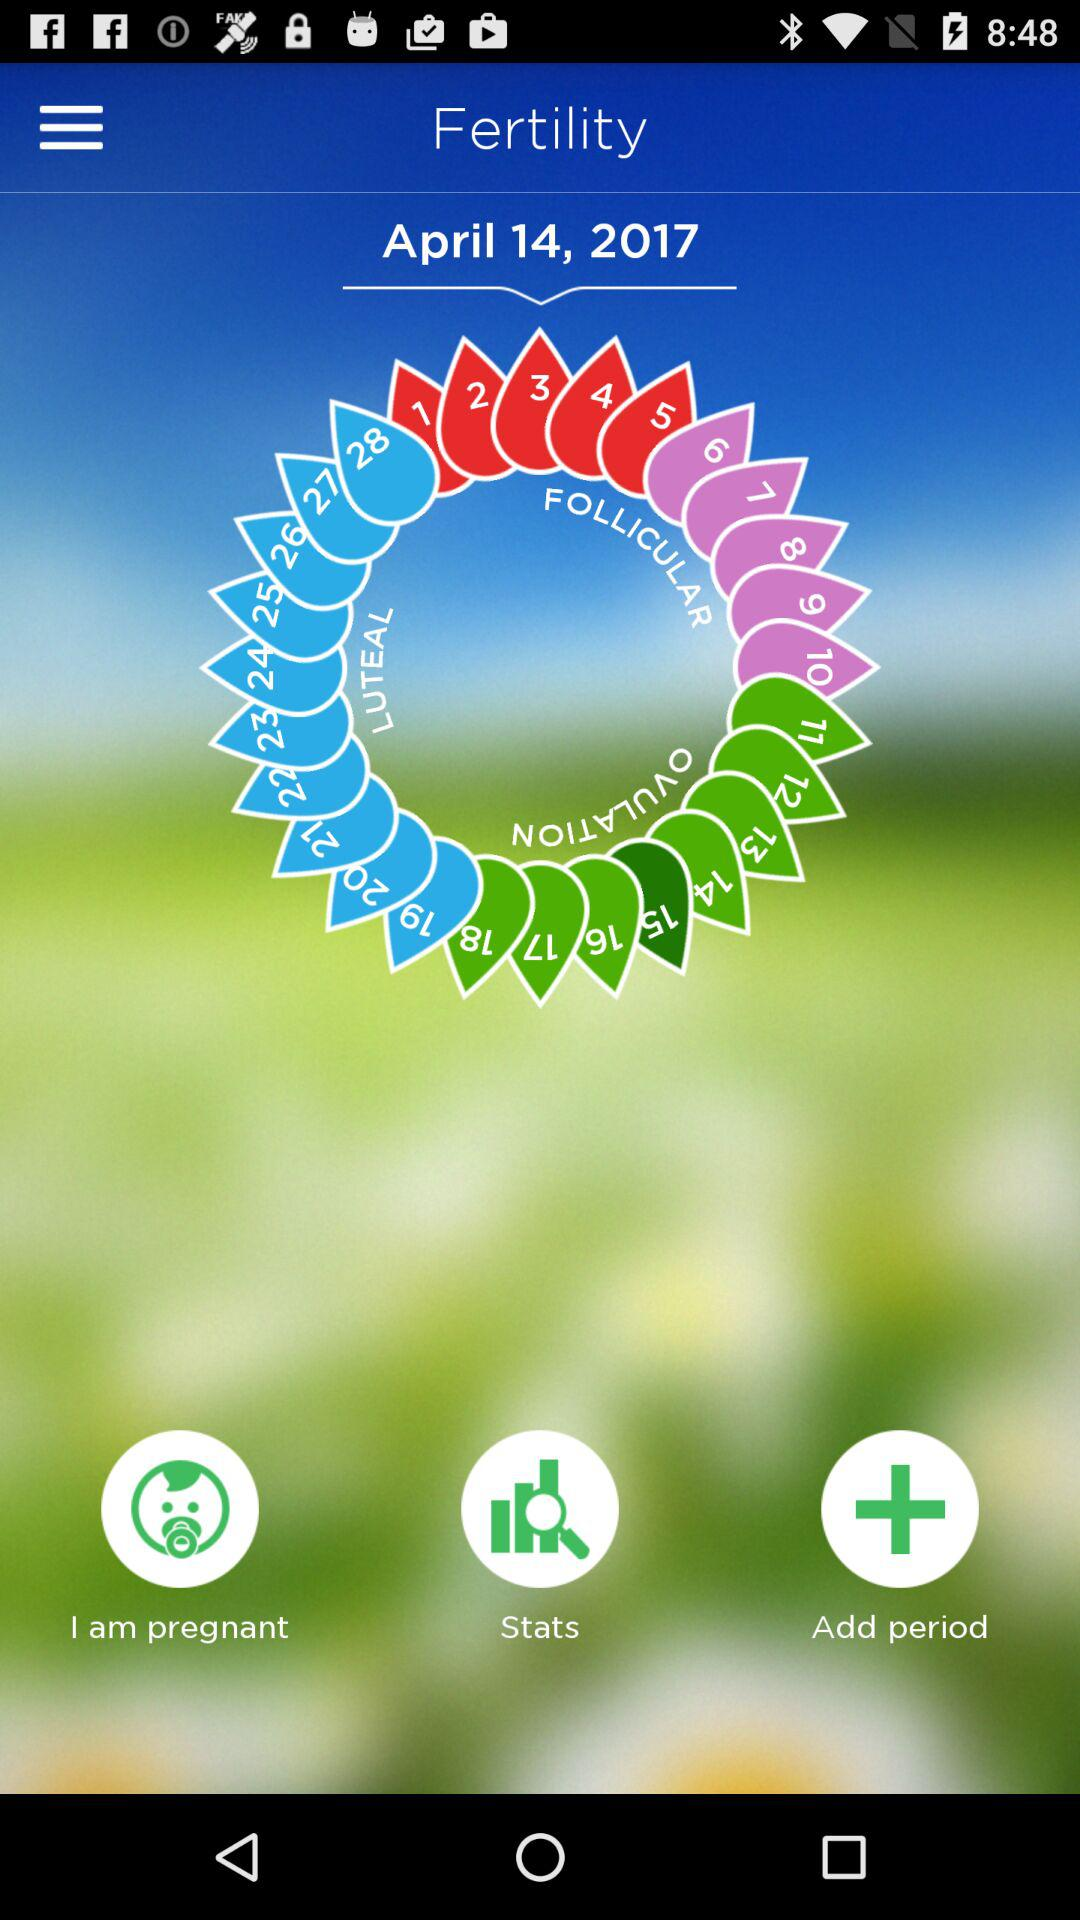What is the mentioned fertility date? The mentioned fertility date is April 14, 2017. 